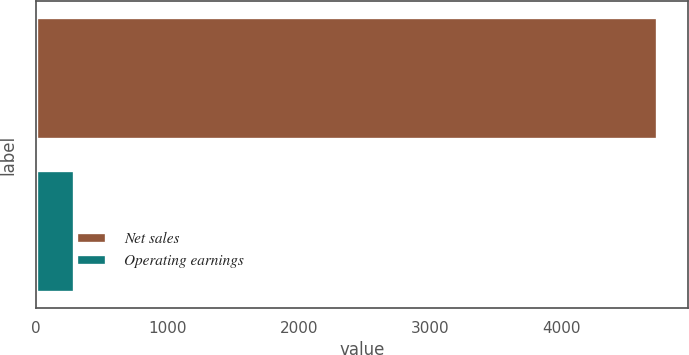Convert chart to OTSL. <chart><loc_0><loc_0><loc_500><loc_500><bar_chart><fcel>Net sales<fcel>Operating earnings<nl><fcel>4726<fcel>292<nl></chart> 